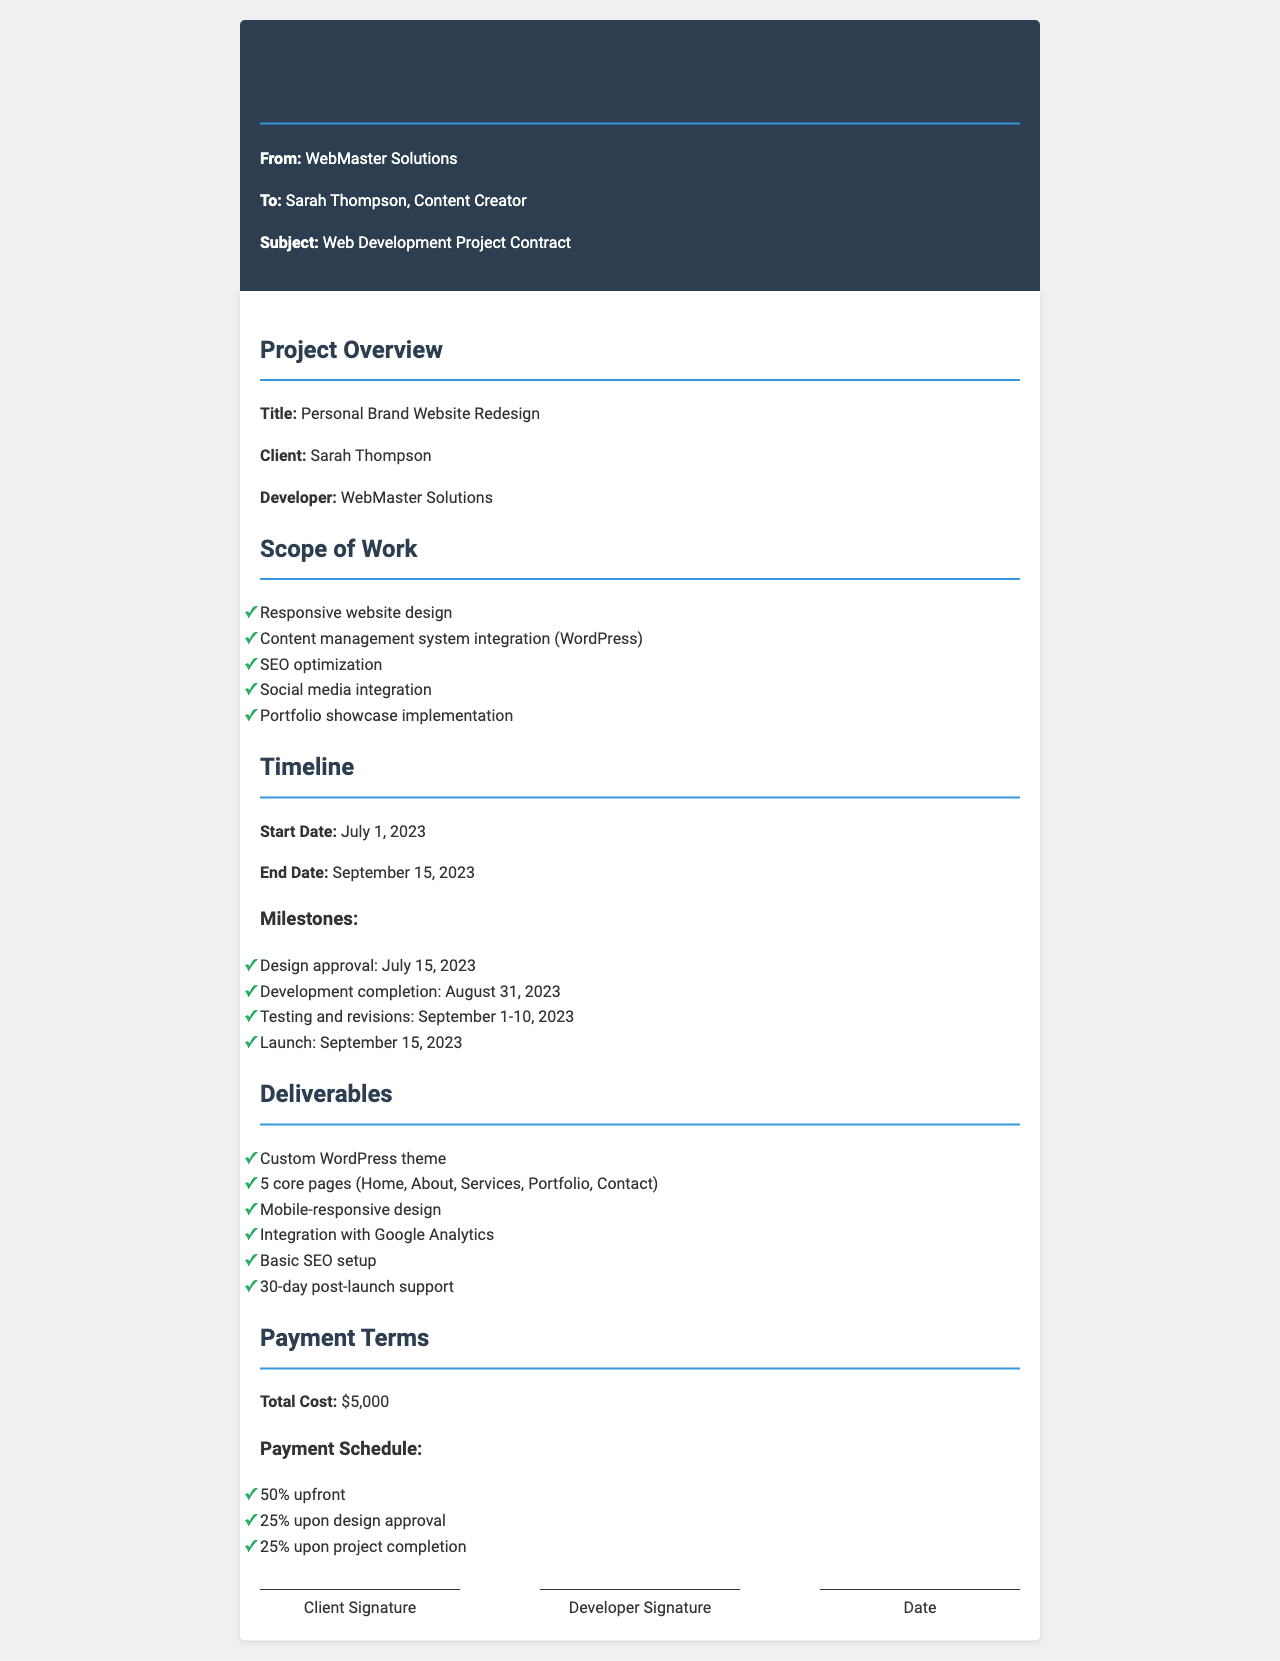what is the project title? The project title is specified in the document overview section as "Personal Brand Website Redesign."
Answer: Personal Brand Website Redesign who is the client? The client is identified in the document as "Sarah Thompson."
Answer: Sarah Thompson what is the total cost of the project? The total cost of the project is listed in the payment terms section as "$5,000."
Answer: $5,000 when is the project start date? The project start date is provided in the timeline section as "July 1, 2023."
Answer: July 1, 2023 how many core pages will be delivered? The number of core pages to be delivered is specified in the deliverables section as "5 core pages."
Answer: 5 core pages what is the deadline for design approval? The deadline for design approval is mentioned in the milestones section as "July 15, 2023."
Answer: July 15, 2023 how long is the post-launch support period? The duration of post-launch support is detailed in the deliverables section as "30-day post-launch support."
Answer: 30-day what percentage is due upon design approval? The percentage due upon design approval is indicated in the payment schedule as "25%."
Answer: 25% who is the developer? The developer is referred to in the document as "WebMaster Solutions."
Answer: WebMaster Solutions 